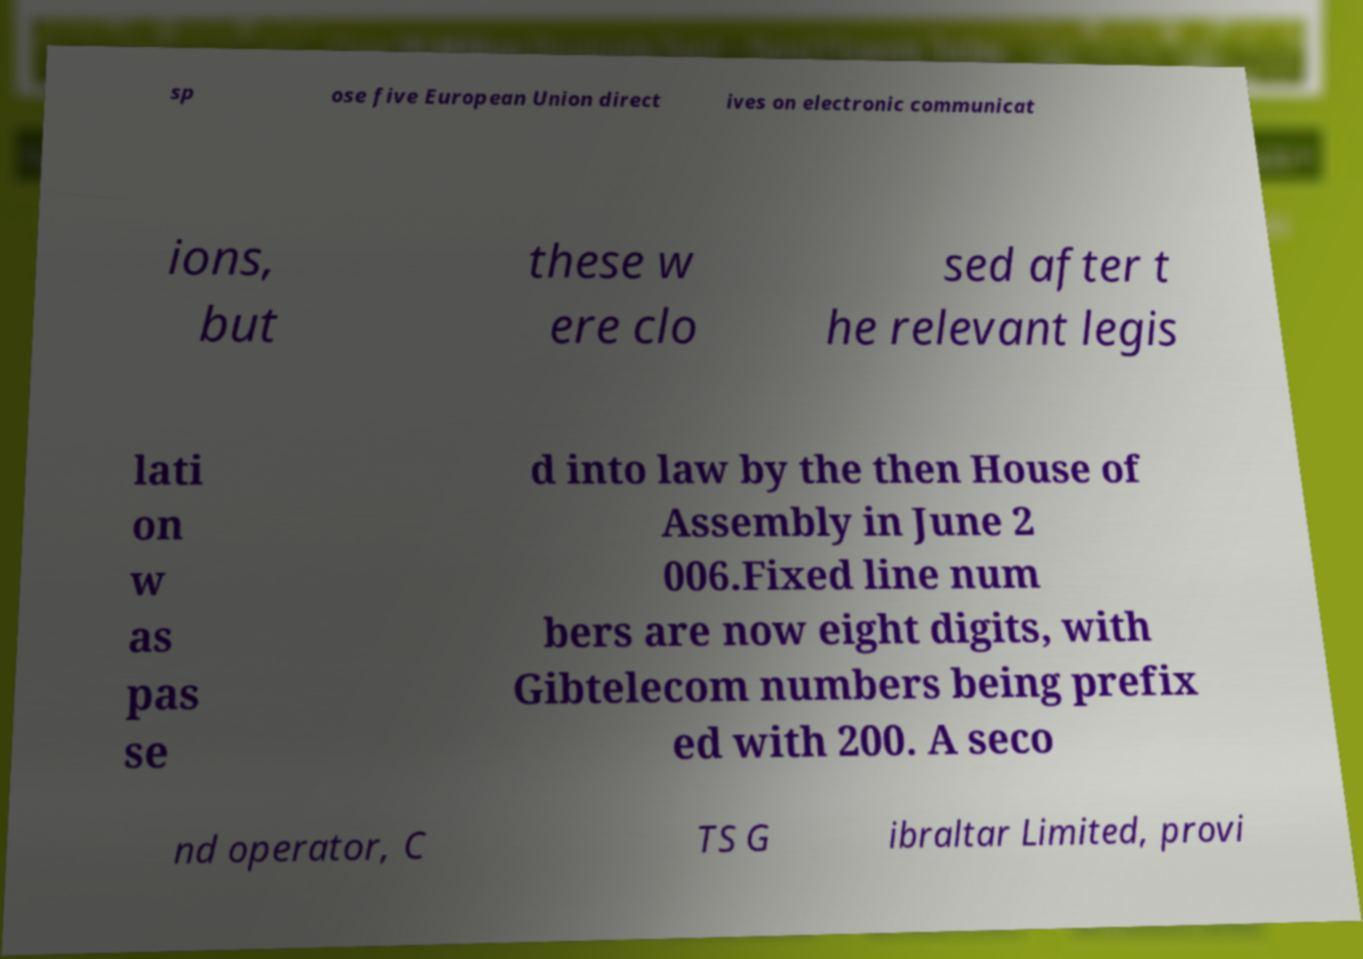There's text embedded in this image that I need extracted. Can you transcribe it verbatim? sp ose five European Union direct ives on electronic communicat ions, but these w ere clo sed after t he relevant legis lati on w as pas se d into law by the then House of Assembly in June 2 006.Fixed line num bers are now eight digits, with Gibtelecom numbers being prefix ed with 200. A seco nd operator, C TS G ibraltar Limited, provi 